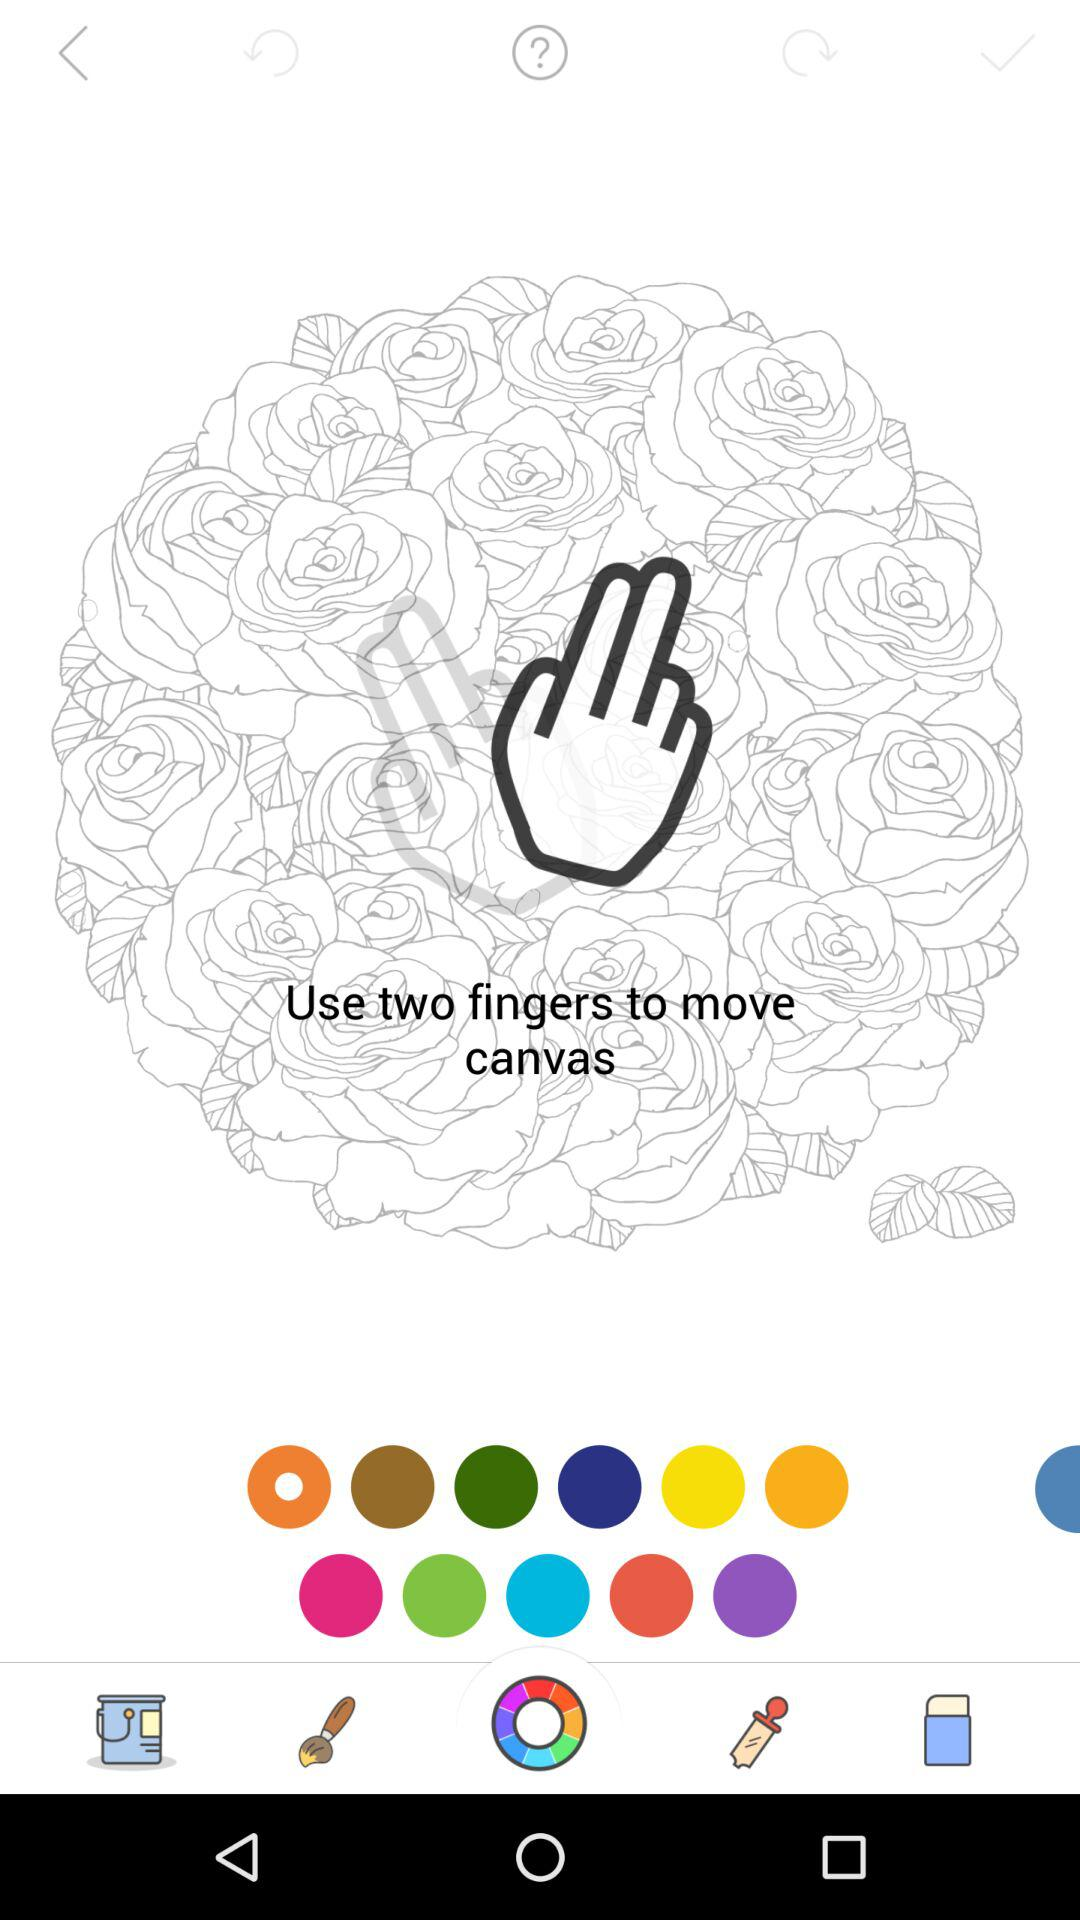How many tickets do I need to unlock the picture?
Answer the question using a single word or phrase. 10 